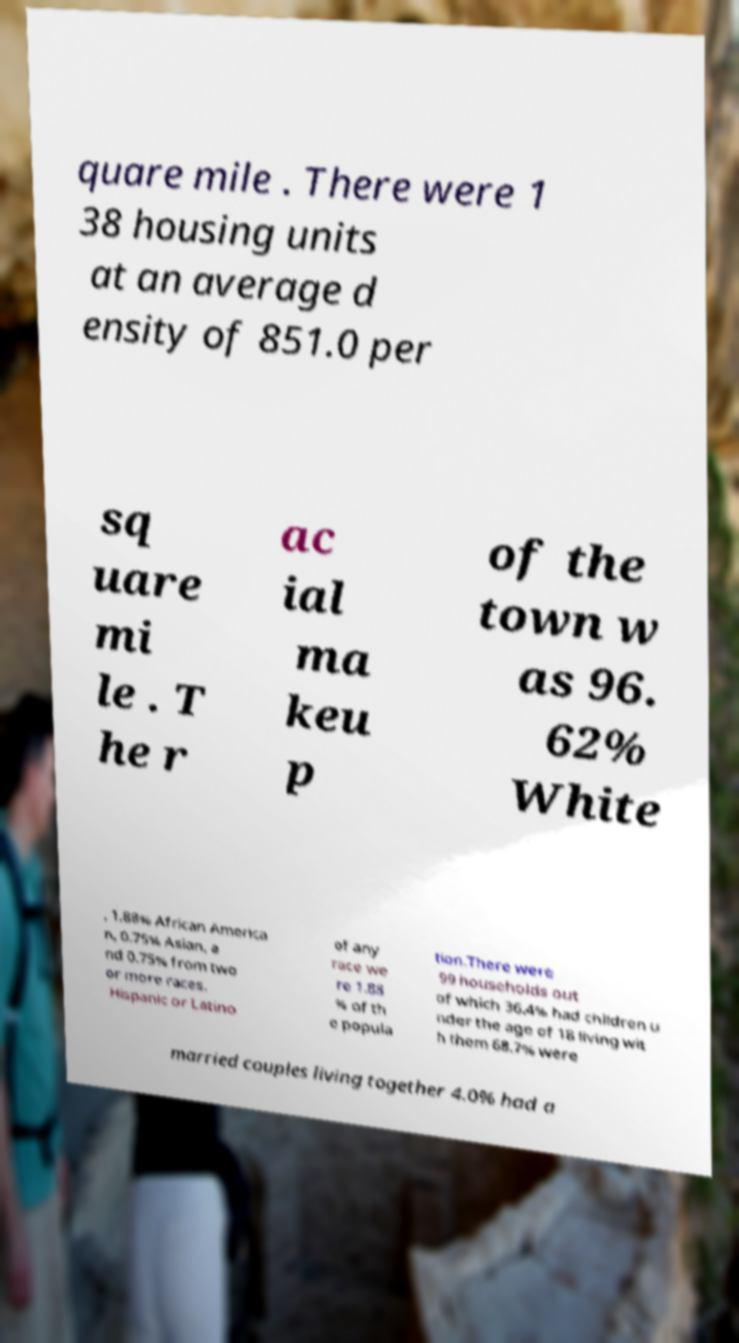Please identify and transcribe the text found in this image. quare mile . There were 1 38 housing units at an average d ensity of 851.0 per sq uare mi le . T he r ac ial ma keu p of the town w as 96. 62% White , 1.88% African America n, 0.75% Asian, a nd 0.75% from two or more races. Hispanic or Latino of any race we re 1.88 % of th e popula tion.There were 99 households out of which 36.4% had children u nder the age of 18 living wit h them 68.7% were married couples living together 4.0% had a 